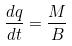Convert formula to latex. <formula><loc_0><loc_0><loc_500><loc_500>\frac { d q } { d t } = \frac { M } { B }</formula> 